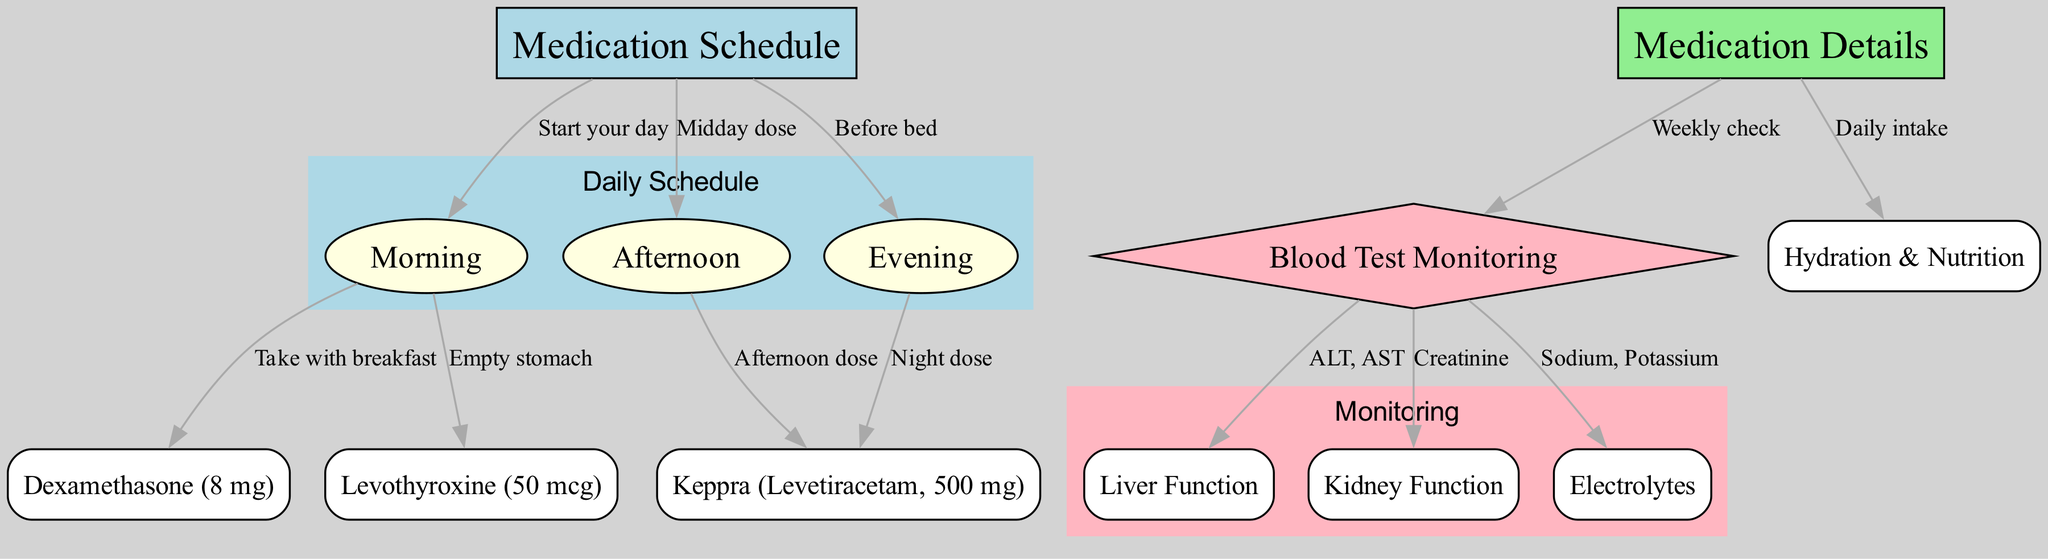What is the total number of nodes in the diagram? The diagram has several nodes, each representing a different element of the medication schedule and monitoring. By counting each unique node listed under "nodes", we find that there are a total of 13 distinct nodes.
Answer: 13 What medication is taken in the morning? The diagram identifies the medications to be taken during different times of the day, including the morning. According to the edges connected to the "Morning" node, Dexamethasone and Levothyroxine are both taken in the morning.
Answer: Dexamethasone and Levothyroxine How many medication dosages are scheduled in the evening? In the diagram, the "Evening" node connects to the "Night dose" for Keppra. Therefore, there is one medication dosage scheduled in the evening.
Answer: 1 What types of health monitoring are included in the diagram? The diagram specifies that blood test monitoring will include checks for liver function, kidney function, and electrolytes. By reviewing the edges connected to the "Blood Test Monitoring" node, we can see these three specific types mentioned.
Answer: Liver Function, Kidney Function, Electrolytes Which medication requires an empty stomach? Looking at the "Afternoon" node connections, it shows that Levothyroxine needs to be taken on an empty stomach. Examining the edges leads us directly to this answer.
Answer: Levothyroxine How are Dexamethasone and Levothyroxine scheduled in relation to each other? The arrows in the diagram illustrate that both Dexamethasone and Levothyroxine are taken in the morning, but are taken at separate moments: Dexamethasone is taken with breakfast, while Levothyroxine is taken on an empty stomach, which implies a sequence.
Answer: Both taken in the morning, separate times What is monitored weekly in this treatment schedule? The diagram features a node labeled "Weekly check" stemming from "Medication Details". This indicates that a weekly blood test monitoring is integral.
Answer: Blood Test Monitoring What aspects of hydration and nutrition are addressed in the treatment? According to the node labeled "Hydration & Nutrition" stemming from "Medication Details", it indicates daily consideration of these aspects in relation to the treatment. Reviewing the edge connection clarifies the inclusion of hydration and nutrition as everyday requirements.
Answer: Daily intake 